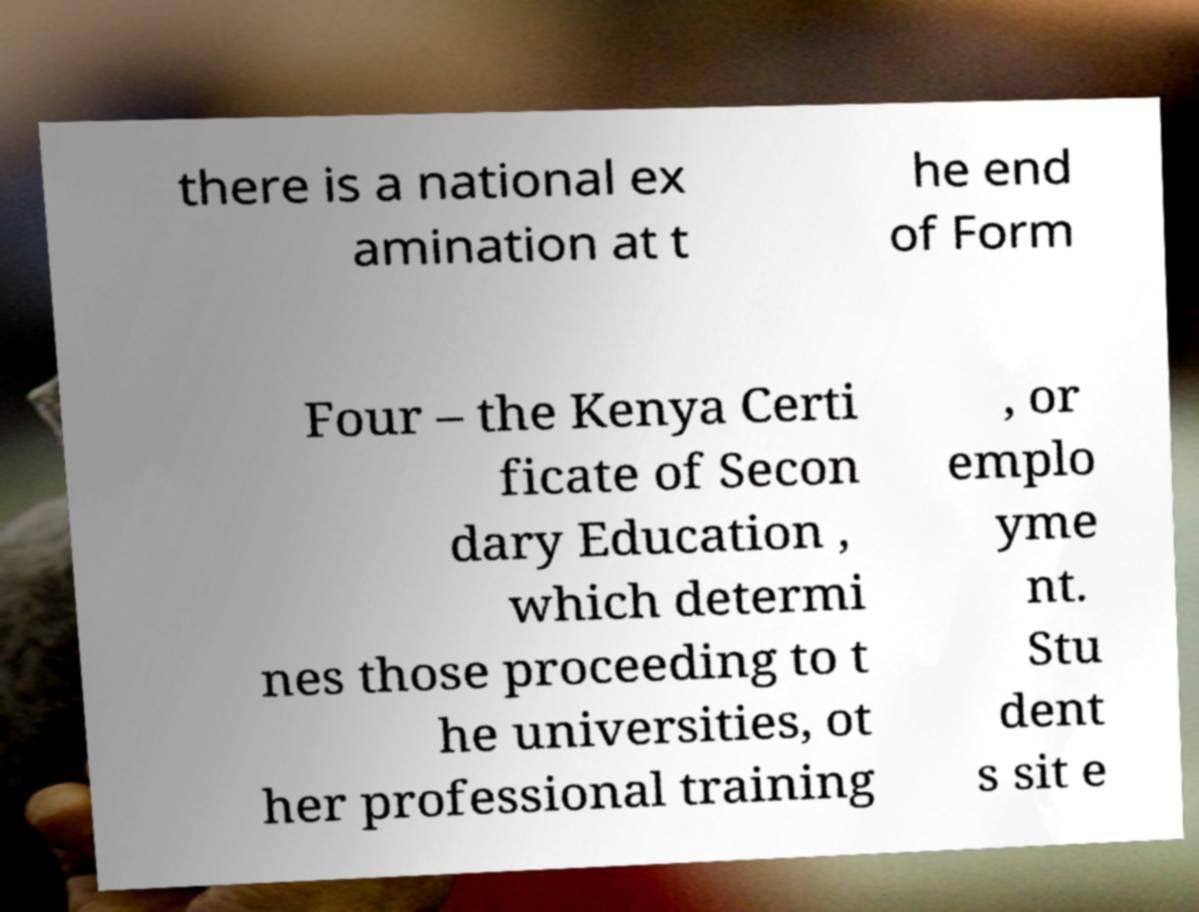Please read and relay the text visible in this image. What does it say? there is a national ex amination at t he end of Form Four – the Kenya Certi ficate of Secon dary Education , which determi nes those proceeding to t he universities, ot her professional training , or emplo yme nt. Stu dent s sit e 